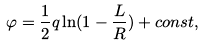<formula> <loc_0><loc_0><loc_500><loc_500>\varphi = \frac { 1 } { 2 } q \ln ( 1 - \frac { L } { R } ) + c o n s t ,</formula> 